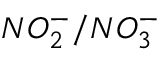<formula> <loc_0><loc_0><loc_500><loc_500>N O _ { 2 } ^ { - } / N O _ { 3 } ^ { - }</formula> 